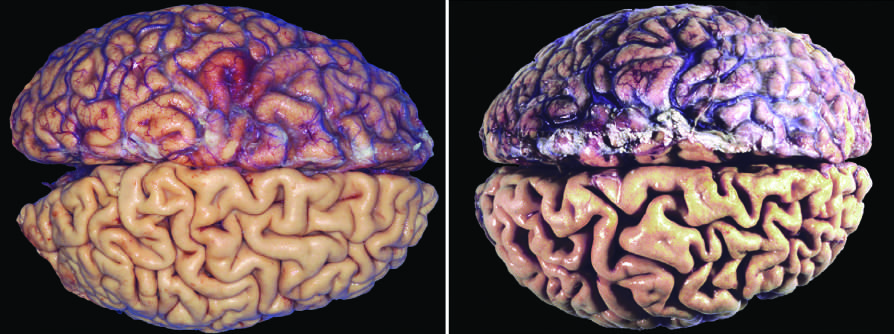what have been stripped from the bottom half of each specimen to show the surface of the brain?
Answer the question using a single word or phrase. The meninges 